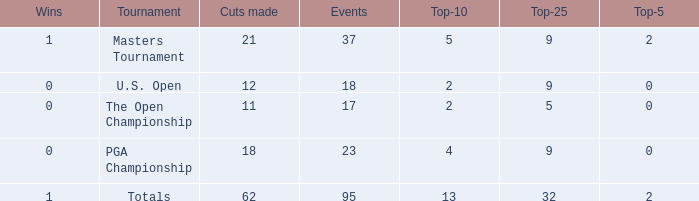What is the average number of cuts made in the Top 25 smaller than 5? None. 